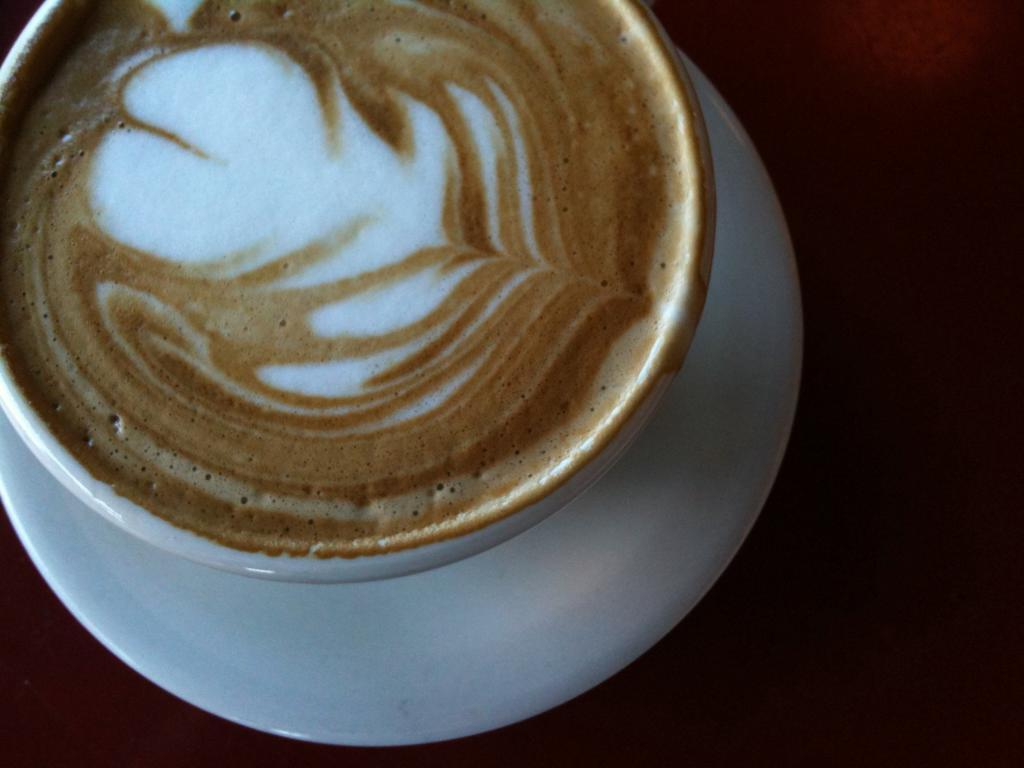What is in the cup that is visible on the left side of the image? There is a cup of tea in the image. Where is the cup of tea located in the image? The cup of tea is on the left side of the image. What is the cup of tea resting on in the image? The cup of tea is on a saucer. What type of pest can be seen crawling on the garden in the image? There is no garden present in the image, so it is not possible to determine if any pests are crawling on it. 